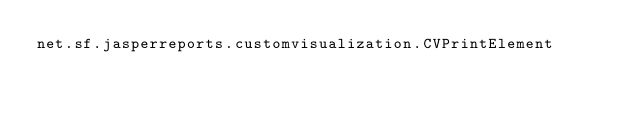Convert code to text. <code><loc_0><loc_0><loc_500><loc_500><_Rust_>net.sf.jasperreports.customvisualization.CVPrintElement
</code> 